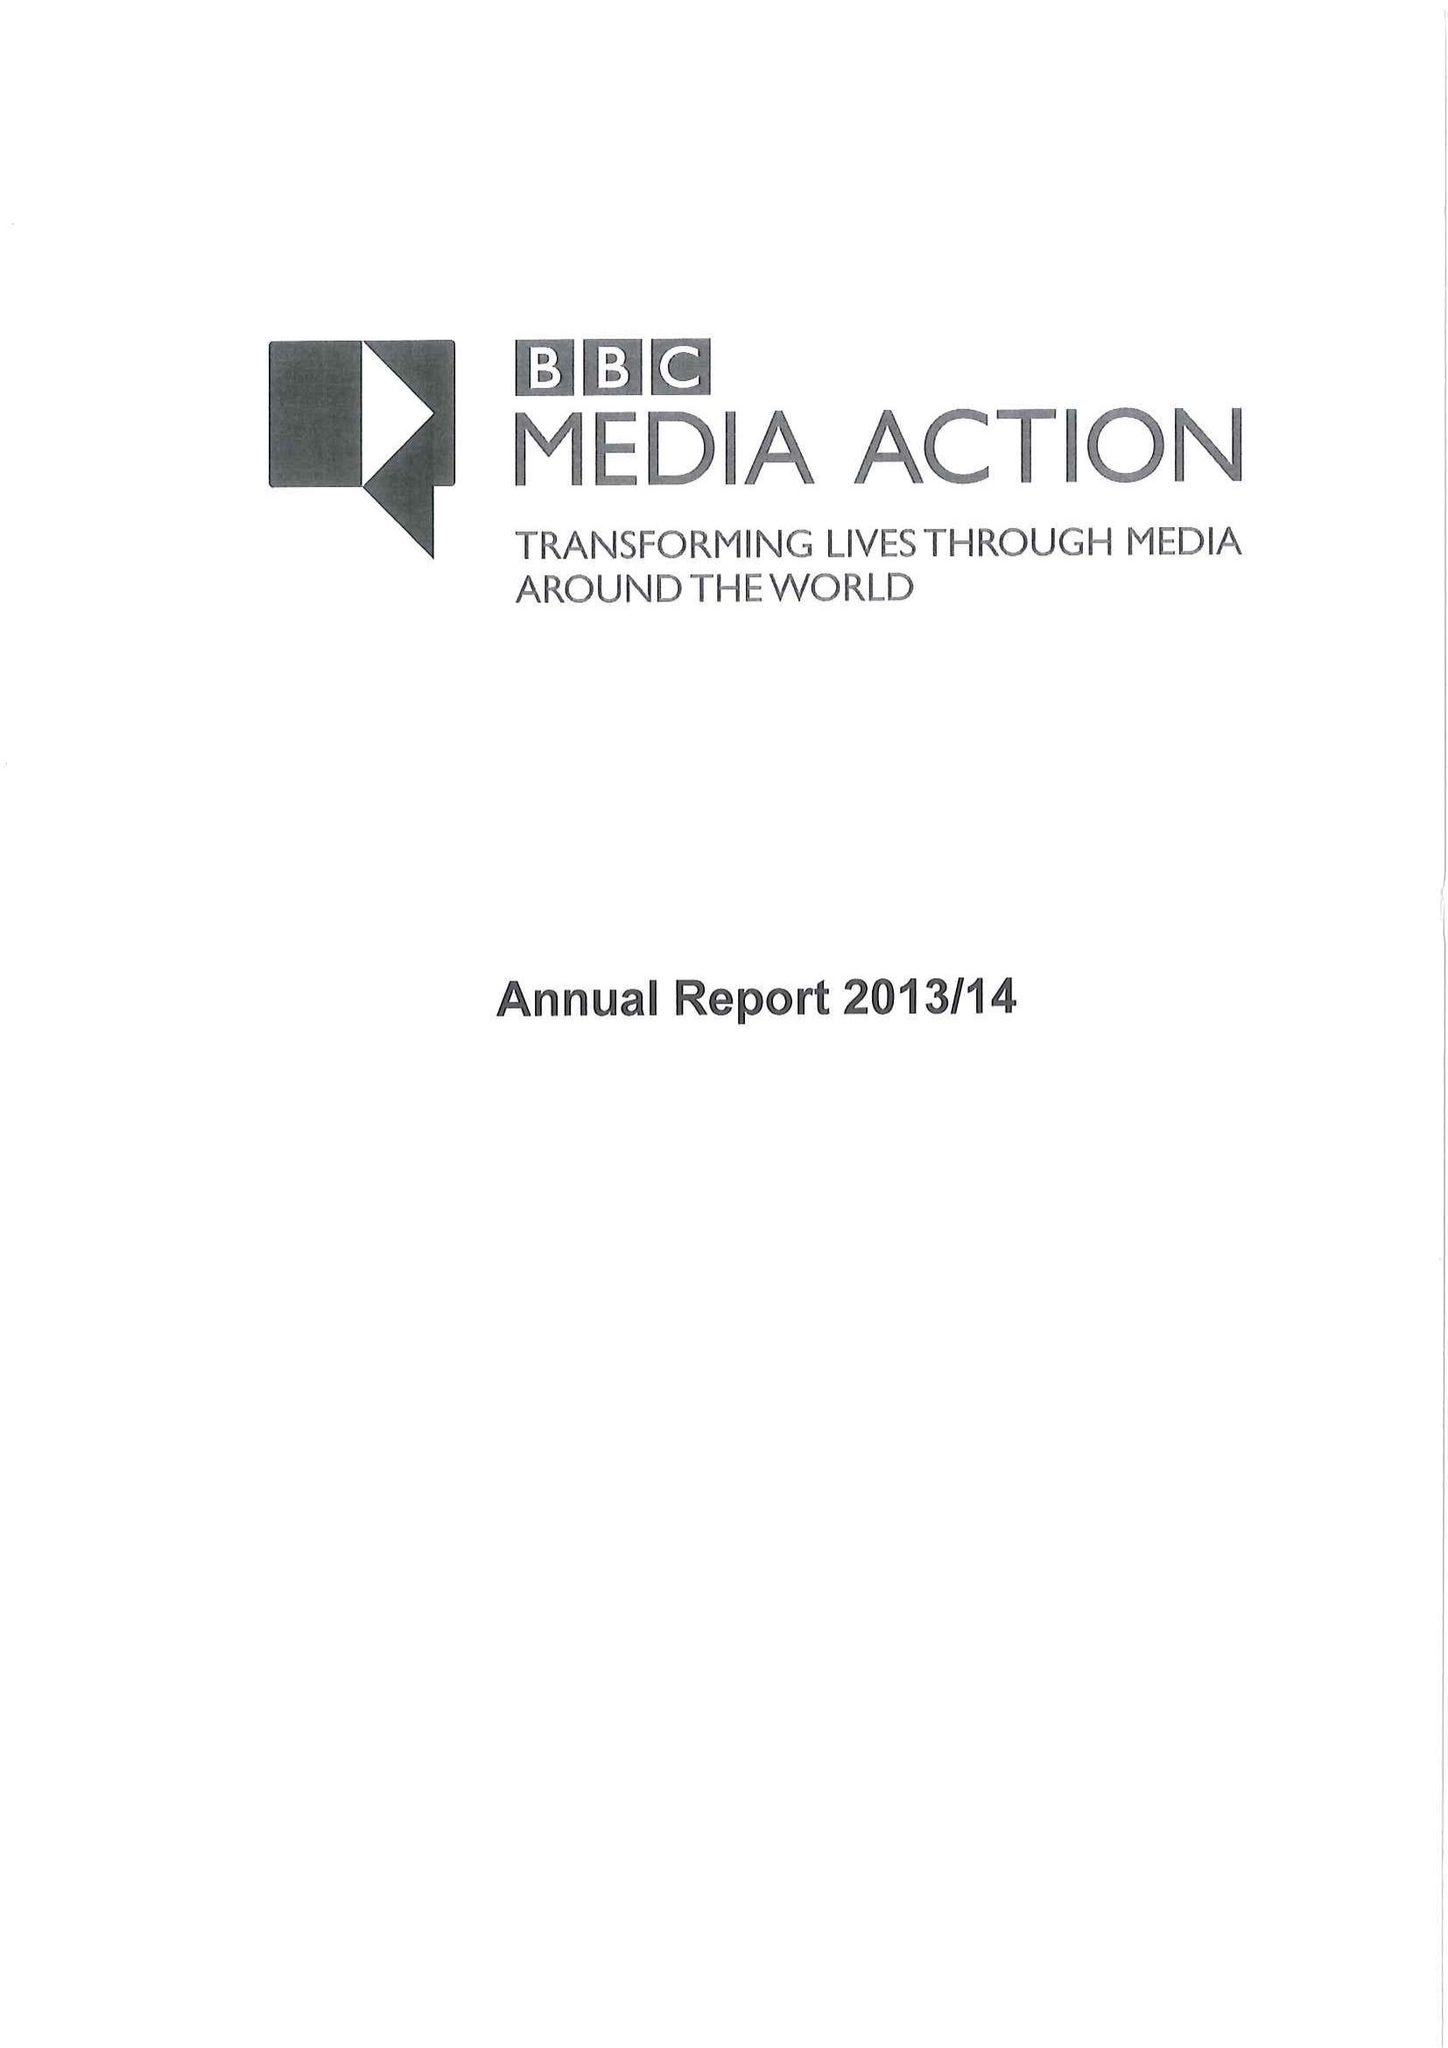What is the value for the spending_annually_in_british_pounds?
Answer the question using a single word or phrase. 40094000.00 